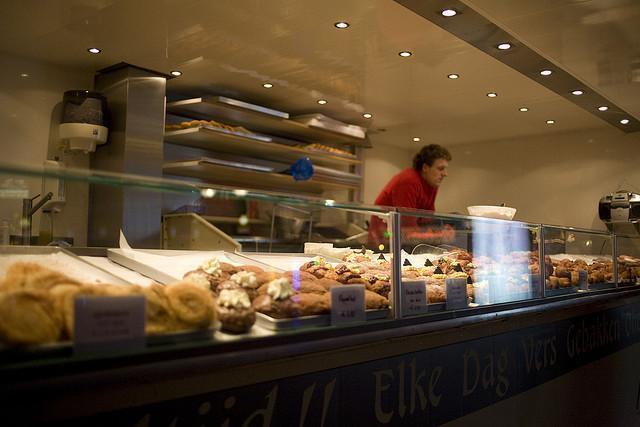How many buses are there going to max north?
Give a very brief answer. 0. 